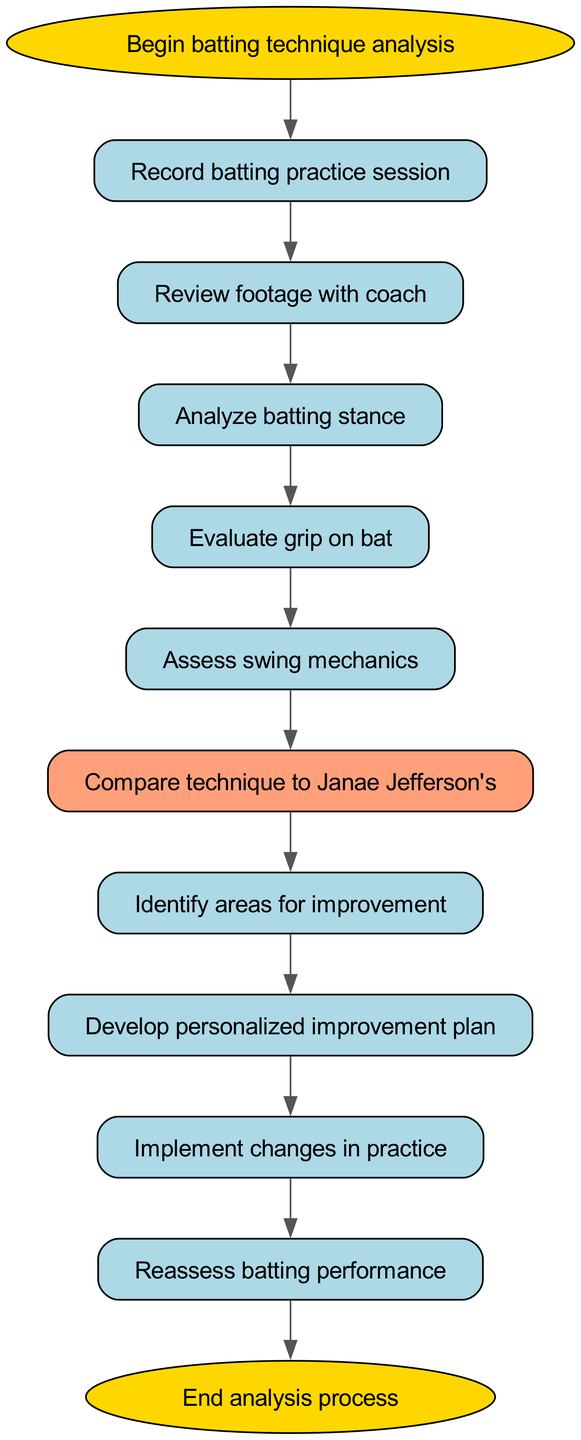What is the first step in the batting technique analysis process? The diagram starts with the node labeled "Begin batting technique analysis," which indicates the first action taken in the process.
Answer: Begin batting technique analysis How many nodes are present in the flowchart? By counting all unique nodes in the diagram, there are a total of 12 distinct nodes.
Answer: 12 What follows after recording the batting practice session? According to the connections, after the "Record batting practice session" node, the next step is "Review footage with coach."
Answer: Review footage with coach Which node evaluates the grip on the bat? The flowchart indicates that the node named "Evaluate grip on bat" is responsible for assessing the grip, making it the direct answer.
Answer: Evaluate grip on bat What is the outcome of comparing technique to Janae Jefferson's? Following the node "Compare technique to Janae Jefferson's," the next step is "Identify areas for improvement," indicating that this comparison leads to identifying issues.
Answer: Identify areas for improvement What is the last step in the analysis process? The diagram indicates that the final action in the flowchart is represented by the node labeled "End analysis process," which concludes the procedure.
Answer: End analysis process What is the step that comes before implementing changes in practice? The flowchart shows that before "Implement changes in practice," the step "Develop personalized improvement plan" must be completed.
Answer: Develop personalized improvement plan How many connections are there in the flowchart? By inspecting the diagram, it's clear that there are 11 connections (edges) established between the nodes, representing the flow of the process.
Answer: 11 What do you do after assessing swing mechanics? After the step in "Assess swing mechanics," the flowchart specifies the next action is "Compare technique to Janae Jefferson's."
Answer: Compare technique to Janae Jefferson's 